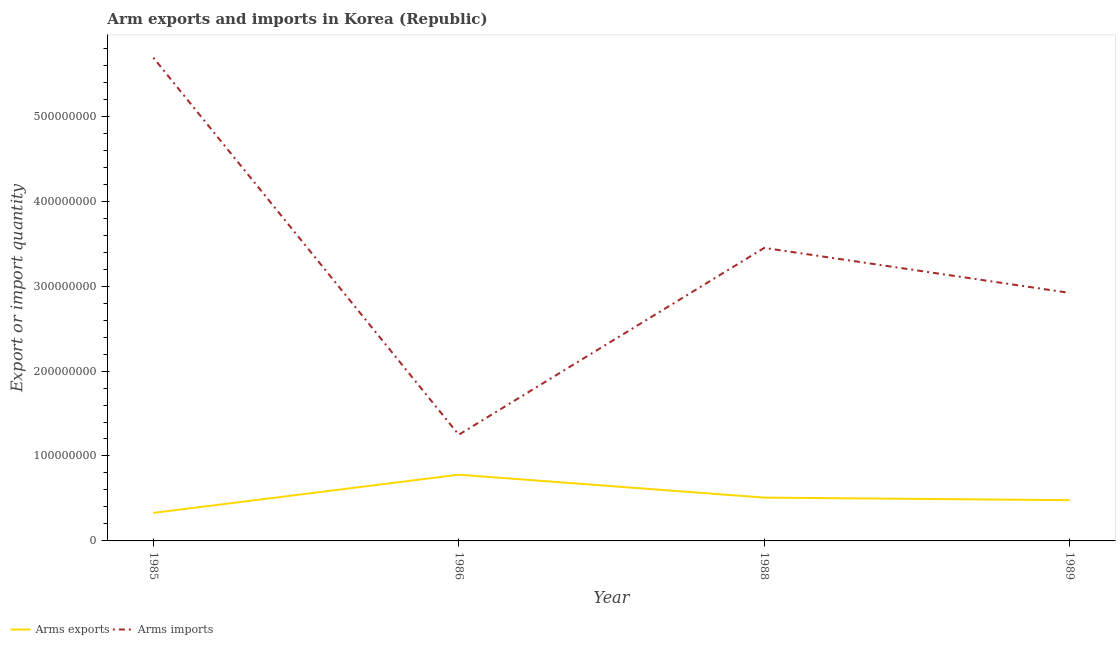Is the number of lines equal to the number of legend labels?
Offer a terse response. Yes. What is the arms imports in 1985?
Your answer should be compact. 5.69e+08. Across all years, what is the maximum arms exports?
Offer a very short reply. 7.80e+07. Across all years, what is the minimum arms imports?
Give a very brief answer. 1.25e+08. In which year was the arms exports maximum?
Provide a short and direct response. 1986. What is the total arms imports in the graph?
Provide a succinct answer. 1.33e+09. What is the difference between the arms exports in 1985 and that in 1986?
Your answer should be very brief. -4.50e+07. What is the difference between the arms imports in 1985 and the arms exports in 1988?
Your response must be concise. 5.18e+08. What is the average arms exports per year?
Your answer should be compact. 5.25e+07. In the year 1989, what is the difference between the arms imports and arms exports?
Your answer should be very brief. 2.44e+08. In how many years, is the arms imports greater than 220000000?
Ensure brevity in your answer.  3. What is the ratio of the arms exports in 1986 to that in 1988?
Give a very brief answer. 1.53. Is the arms exports in 1986 less than that in 1988?
Your answer should be very brief. No. Is the difference between the arms exports in 1985 and 1986 greater than the difference between the arms imports in 1985 and 1986?
Provide a short and direct response. No. What is the difference between the highest and the second highest arms exports?
Provide a succinct answer. 2.70e+07. What is the difference between the highest and the lowest arms exports?
Offer a terse response. 4.50e+07. In how many years, is the arms imports greater than the average arms imports taken over all years?
Your response must be concise. 2. How many lines are there?
Your answer should be compact. 2. How many years are there in the graph?
Keep it short and to the point. 4. What is the difference between two consecutive major ticks on the Y-axis?
Offer a terse response. 1.00e+08. Are the values on the major ticks of Y-axis written in scientific E-notation?
Ensure brevity in your answer.  No. Does the graph contain any zero values?
Ensure brevity in your answer.  No. Where does the legend appear in the graph?
Give a very brief answer. Bottom left. How are the legend labels stacked?
Keep it short and to the point. Horizontal. What is the title of the graph?
Your answer should be compact. Arm exports and imports in Korea (Republic). What is the label or title of the Y-axis?
Your response must be concise. Export or import quantity. What is the Export or import quantity in Arms exports in 1985?
Offer a terse response. 3.30e+07. What is the Export or import quantity of Arms imports in 1985?
Provide a short and direct response. 5.69e+08. What is the Export or import quantity in Arms exports in 1986?
Your answer should be very brief. 7.80e+07. What is the Export or import quantity in Arms imports in 1986?
Make the answer very short. 1.25e+08. What is the Export or import quantity of Arms exports in 1988?
Your answer should be compact. 5.10e+07. What is the Export or import quantity in Arms imports in 1988?
Your response must be concise. 3.45e+08. What is the Export or import quantity in Arms exports in 1989?
Give a very brief answer. 4.80e+07. What is the Export or import quantity in Arms imports in 1989?
Offer a very short reply. 2.92e+08. Across all years, what is the maximum Export or import quantity of Arms exports?
Offer a very short reply. 7.80e+07. Across all years, what is the maximum Export or import quantity in Arms imports?
Provide a short and direct response. 5.69e+08. Across all years, what is the minimum Export or import quantity in Arms exports?
Offer a terse response. 3.30e+07. Across all years, what is the minimum Export or import quantity of Arms imports?
Ensure brevity in your answer.  1.25e+08. What is the total Export or import quantity of Arms exports in the graph?
Offer a terse response. 2.10e+08. What is the total Export or import quantity of Arms imports in the graph?
Offer a terse response. 1.33e+09. What is the difference between the Export or import quantity in Arms exports in 1985 and that in 1986?
Make the answer very short. -4.50e+07. What is the difference between the Export or import quantity of Arms imports in 1985 and that in 1986?
Ensure brevity in your answer.  4.44e+08. What is the difference between the Export or import quantity of Arms exports in 1985 and that in 1988?
Ensure brevity in your answer.  -1.80e+07. What is the difference between the Export or import quantity in Arms imports in 1985 and that in 1988?
Give a very brief answer. 2.24e+08. What is the difference between the Export or import quantity of Arms exports in 1985 and that in 1989?
Offer a terse response. -1.50e+07. What is the difference between the Export or import quantity of Arms imports in 1985 and that in 1989?
Keep it short and to the point. 2.77e+08. What is the difference between the Export or import quantity of Arms exports in 1986 and that in 1988?
Give a very brief answer. 2.70e+07. What is the difference between the Export or import quantity in Arms imports in 1986 and that in 1988?
Your answer should be compact. -2.20e+08. What is the difference between the Export or import quantity in Arms exports in 1986 and that in 1989?
Provide a succinct answer. 3.00e+07. What is the difference between the Export or import quantity of Arms imports in 1986 and that in 1989?
Your answer should be very brief. -1.67e+08. What is the difference between the Export or import quantity of Arms imports in 1988 and that in 1989?
Your answer should be very brief. 5.30e+07. What is the difference between the Export or import quantity of Arms exports in 1985 and the Export or import quantity of Arms imports in 1986?
Offer a very short reply. -9.20e+07. What is the difference between the Export or import quantity in Arms exports in 1985 and the Export or import quantity in Arms imports in 1988?
Ensure brevity in your answer.  -3.12e+08. What is the difference between the Export or import quantity of Arms exports in 1985 and the Export or import quantity of Arms imports in 1989?
Provide a short and direct response. -2.59e+08. What is the difference between the Export or import quantity in Arms exports in 1986 and the Export or import quantity in Arms imports in 1988?
Your response must be concise. -2.67e+08. What is the difference between the Export or import quantity in Arms exports in 1986 and the Export or import quantity in Arms imports in 1989?
Your answer should be very brief. -2.14e+08. What is the difference between the Export or import quantity of Arms exports in 1988 and the Export or import quantity of Arms imports in 1989?
Make the answer very short. -2.41e+08. What is the average Export or import quantity of Arms exports per year?
Ensure brevity in your answer.  5.25e+07. What is the average Export or import quantity of Arms imports per year?
Provide a succinct answer. 3.33e+08. In the year 1985, what is the difference between the Export or import quantity in Arms exports and Export or import quantity in Arms imports?
Your response must be concise. -5.36e+08. In the year 1986, what is the difference between the Export or import quantity of Arms exports and Export or import quantity of Arms imports?
Provide a succinct answer. -4.70e+07. In the year 1988, what is the difference between the Export or import quantity of Arms exports and Export or import quantity of Arms imports?
Give a very brief answer. -2.94e+08. In the year 1989, what is the difference between the Export or import quantity of Arms exports and Export or import quantity of Arms imports?
Your answer should be very brief. -2.44e+08. What is the ratio of the Export or import quantity of Arms exports in 1985 to that in 1986?
Your response must be concise. 0.42. What is the ratio of the Export or import quantity in Arms imports in 1985 to that in 1986?
Your response must be concise. 4.55. What is the ratio of the Export or import quantity of Arms exports in 1985 to that in 1988?
Keep it short and to the point. 0.65. What is the ratio of the Export or import quantity of Arms imports in 1985 to that in 1988?
Provide a short and direct response. 1.65. What is the ratio of the Export or import quantity of Arms exports in 1985 to that in 1989?
Make the answer very short. 0.69. What is the ratio of the Export or import quantity of Arms imports in 1985 to that in 1989?
Your answer should be very brief. 1.95. What is the ratio of the Export or import quantity in Arms exports in 1986 to that in 1988?
Give a very brief answer. 1.53. What is the ratio of the Export or import quantity in Arms imports in 1986 to that in 1988?
Your answer should be compact. 0.36. What is the ratio of the Export or import quantity in Arms exports in 1986 to that in 1989?
Your response must be concise. 1.62. What is the ratio of the Export or import quantity in Arms imports in 1986 to that in 1989?
Offer a terse response. 0.43. What is the ratio of the Export or import quantity of Arms exports in 1988 to that in 1989?
Offer a terse response. 1.06. What is the ratio of the Export or import quantity in Arms imports in 1988 to that in 1989?
Make the answer very short. 1.18. What is the difference between the highest and the second highest Export or import quantity in Arms exports?
Your response must be concise. 2.70e+07. What is the difference between the highest and the second highest Export or import quantity of Arms imports?
Your answer should be very brief. 2.24e+08. What is the difference between the highest and the lowest Export or import quantity in Arms exports?
Ensure brevity in your answer.  4.50e+07. What is the difference between the highest and the lowest Export or import quantity in Arms imports?
Provide a succinct answer. 4.44e+08. 